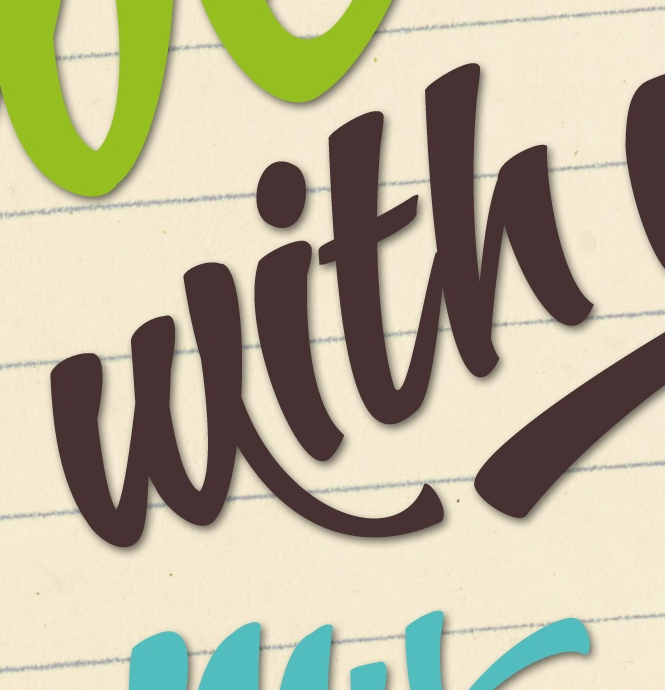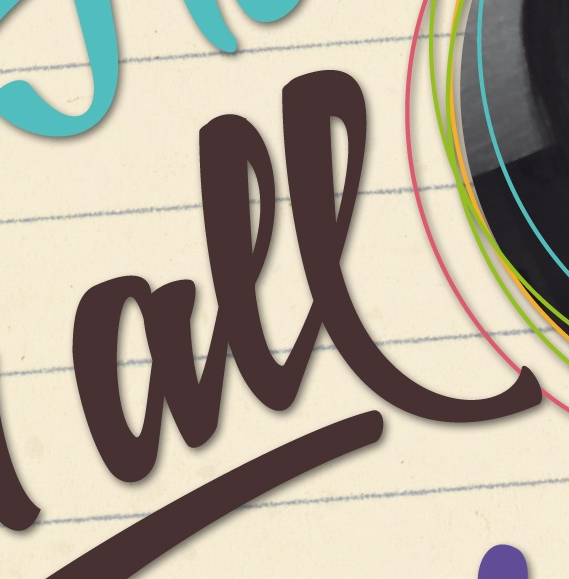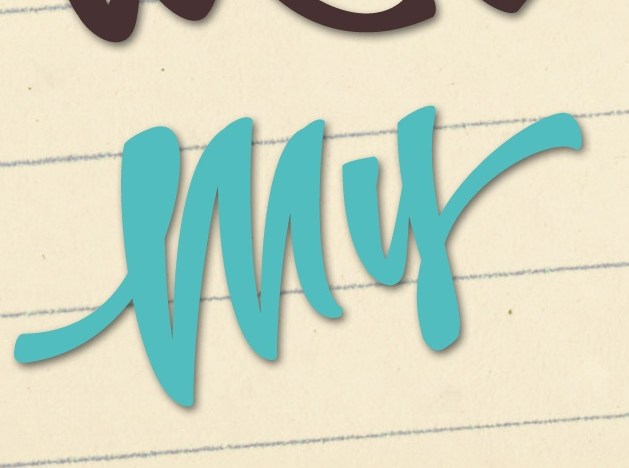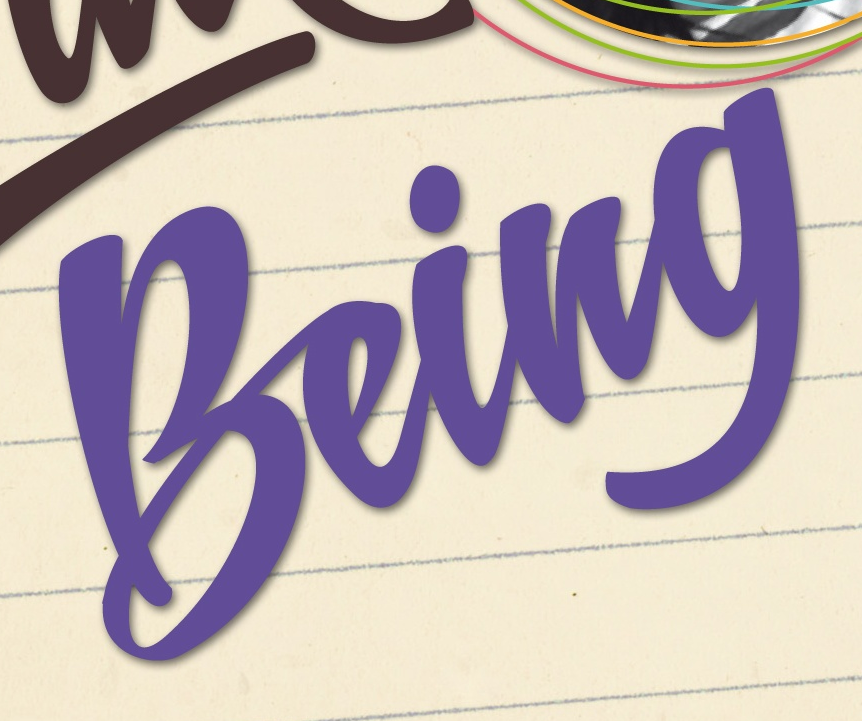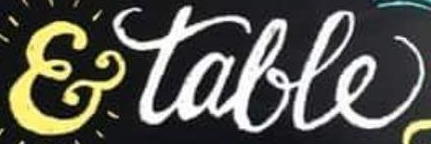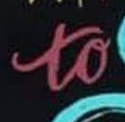What text is displayed in these images sequentially, separated by a semicolon? with; all; my; being; &talle; to 